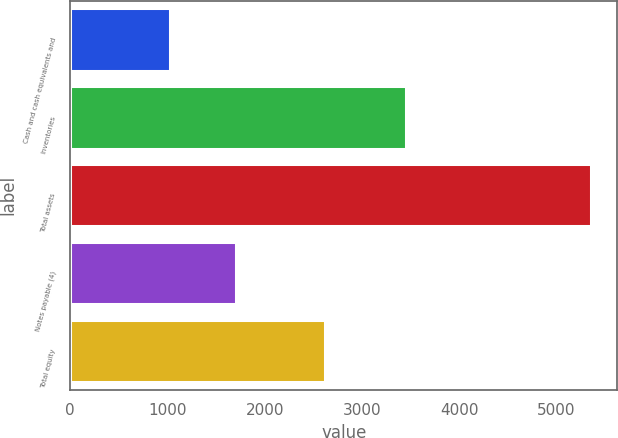Convert chart. <chart><loc_0><loc_0><loc_500><loc_500><bar_chart><fcel>Cash and cash equivalents and<fcel>Inventories<fcel>Total assets<fcel>Notes payable (4)<fcel>Total equity<nl><fcel>1030.2<fcel>3449.7<fcel>5358.4<fcel>1704.6<fcel>2623.5<nl></chart> 